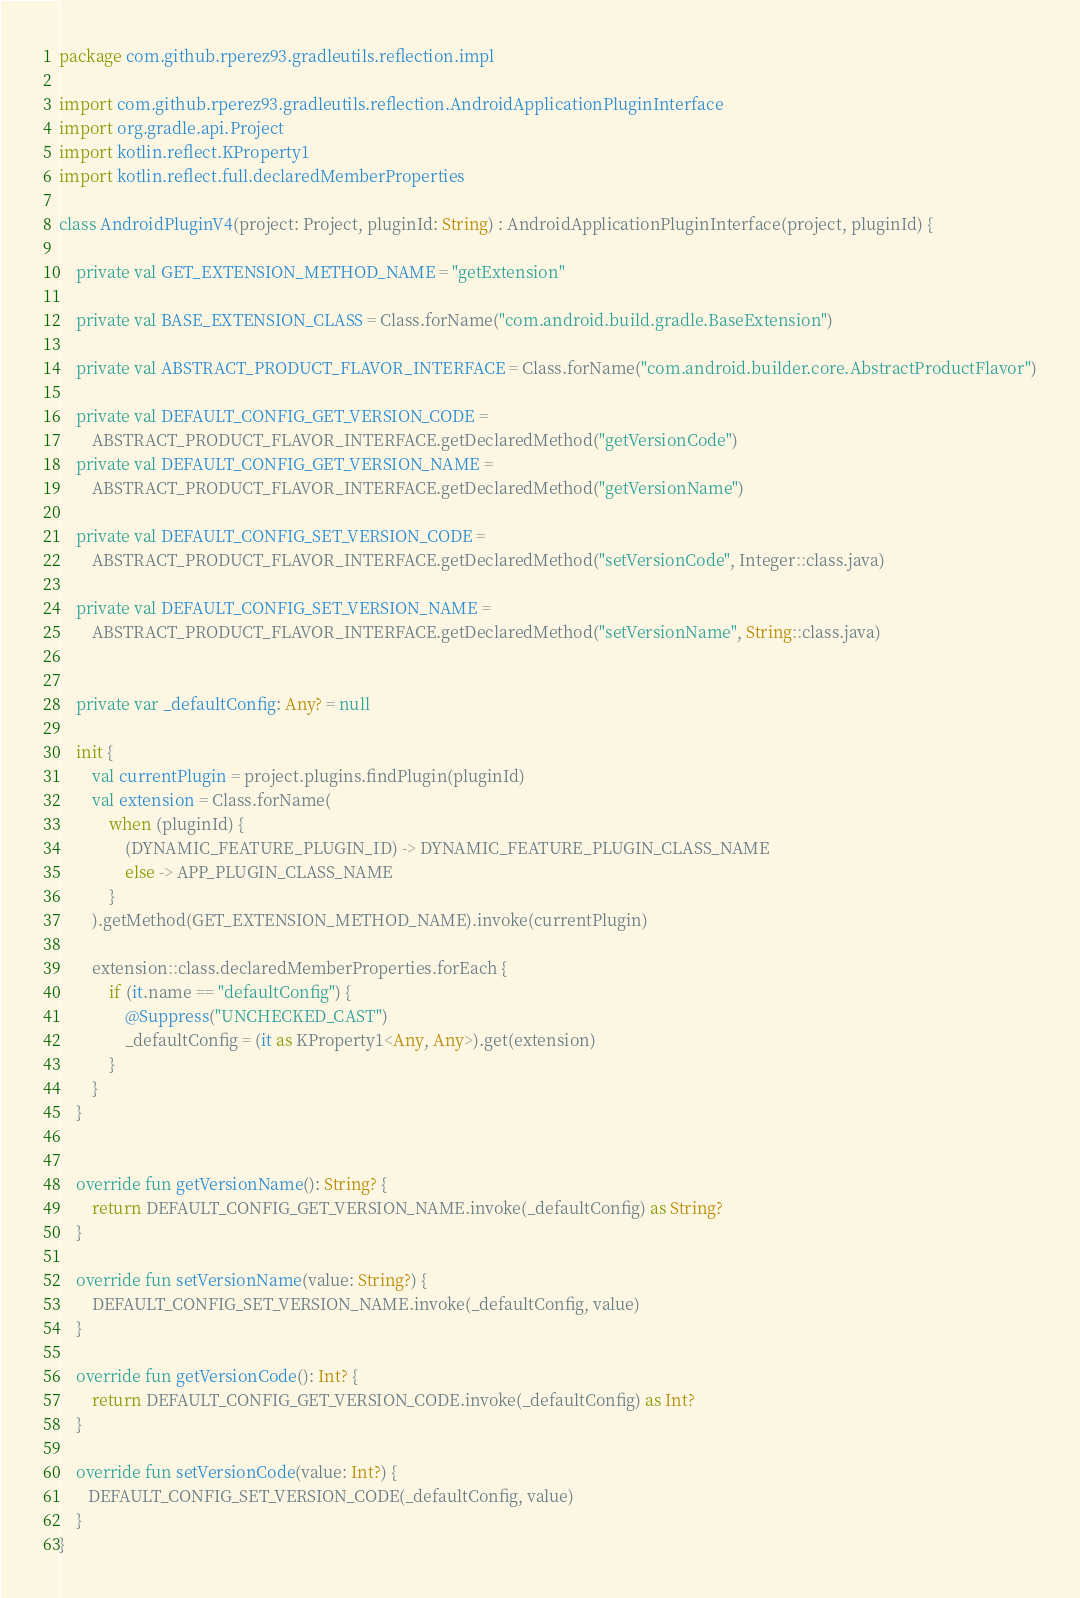<code> <loc_0><loc_0><loc_500><loc_500><_Kotlin_>package com.github.rperez93.gradleutils.reflection.impl

import com.github.rperez93.gradleutils.reflection.AndroidApplicationPluginInterface
import org.gradle.api.Project
import kotlin.reflect.KProperty1
import kotlin.reflect.full.declaredMemberProperties

class AndroidPluginV4(project: Project, pluginId: String) : AndroidApplicationPluginInterface(project, pluginId) {

    private val GET_EXTENSION_METHOD_NAME = "getExtension"

    private val BASE_EXTENSION_CLASS = Class.forName("com.android.build.gradle.BaseExtension")

    private val ABSTRACT_PRODUCT_FLAVOR_INTERFACE = Class.forName("com.android.builder.core.AbstractProductFlavor")

    private val DEFAULT_CONFIG_GET_VERSION_CODE =
        ABSTRACT_PRODUCT_FLAVOR_INTERFACE.getDeclaredMethod("getVersionCode")
    private val DEFAULT_CONFIG_GET_VERSION_NAME =
        ABSTRACT_PRODUCT_FLAVOR_INTERFACE.getDeclaredMethod("getVersionName")

    private val DEFAULT_CONFIG_SET_VERSION_CODE =
        ABSTRACT_PRODUCT_FLAVOR_INTERFACE.getDeclaredMethod("setVersionCode", Integer::class.java)

    private val DEFAULT_CONFIG_SET_VERSION_NAME =
        ABSTRACT_PRODUCT_FLAVOR_INTERFACE.getDeclaredMethod("setVersionName", String::class.java)


    private var _defaultConfig: Any? = null

    init {
        val currentPlugin = project.plugins.findPlugin(pluginId)
        val extension = Class.forName(
            when (pluginId) {
                (DYNAMIC_FEATURE_PLUGIN_ID) -> DYNAMIC_FEATURE_PLUGIN_CLASS_NAME
                else -> APP_PLUGIN_CLASS_NAME
            }
        ).getMethod(GET_EXTENSION_METHOD_NAME).invoke(currentPlugin)

        extension::class.declaredMemberProperties.forEach {
            if (it.name == "defaultConfig") {
                @Suppress("UNCHECKED_CAST")
                _defaultConfig = (it as KProperty1<Any, Any>).get(extension)
            }
        }
    }


    override fun getVersionName(): String? {
        return DEFAULT_CONFIG_GET_VERSION_NAME.invoke(_defaultConfig) as String?
    }

    override fun setVersionName(value: String?) {
        DEFAULT_CONFIG_SET_VERSION_NAME.invoke(_defaultConfig, value)
    }

    override fun getVersionCode(): Int? {
        return DEFAULT_CONFIG_GET_VERSION_CODE.invoke(_defaultConfig) as Int?
    }

    override fun setVersionCode(value: Int?) {
       DEFAULT_CONFIG_SET_VERSION_CODE(_defaultConfig, value)
    }
}</code> 